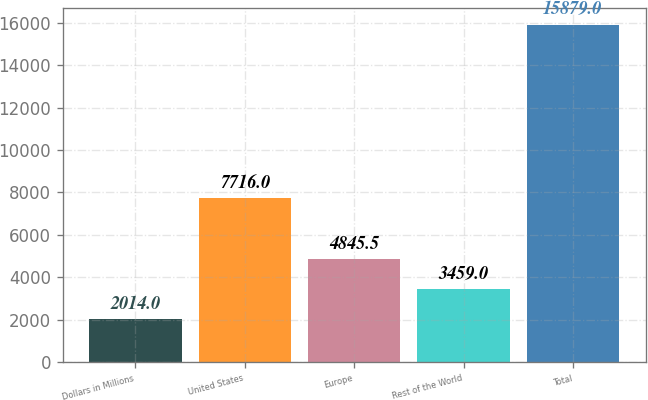Convert chart. <chart><loc_0><loc_0><loc_500><loc_500><bar_chart><fcel>Dollars in Millions<fcel>United States<fcel>Europe<fcel>Rest of the World<fcel>Total<nl><fcel>2014<fcel>7716<fcel>4845.5<fcel>3459<fcel>15879<nl></chart> 